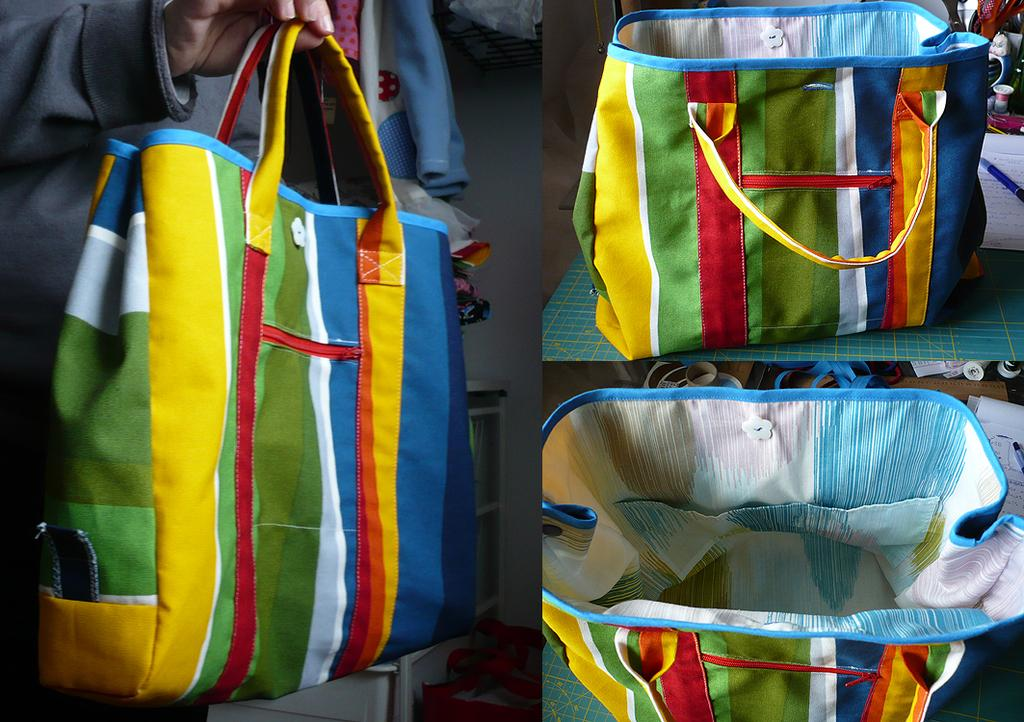How many pictures are included in the collage? The image is a collage of three pictures. What object can be seen in one of the pictures? There is a bag in one of the pictures. How can the bag be described in terms of its appearance? The bag has colorful stripes. What colors are present in the stripes on the bag? The stripes are in blue, yellow, orange, and green colors. What shape is the tongue of the person in the image? There is no person present in the image, so it is not possible to determine the shape of their tongue. 